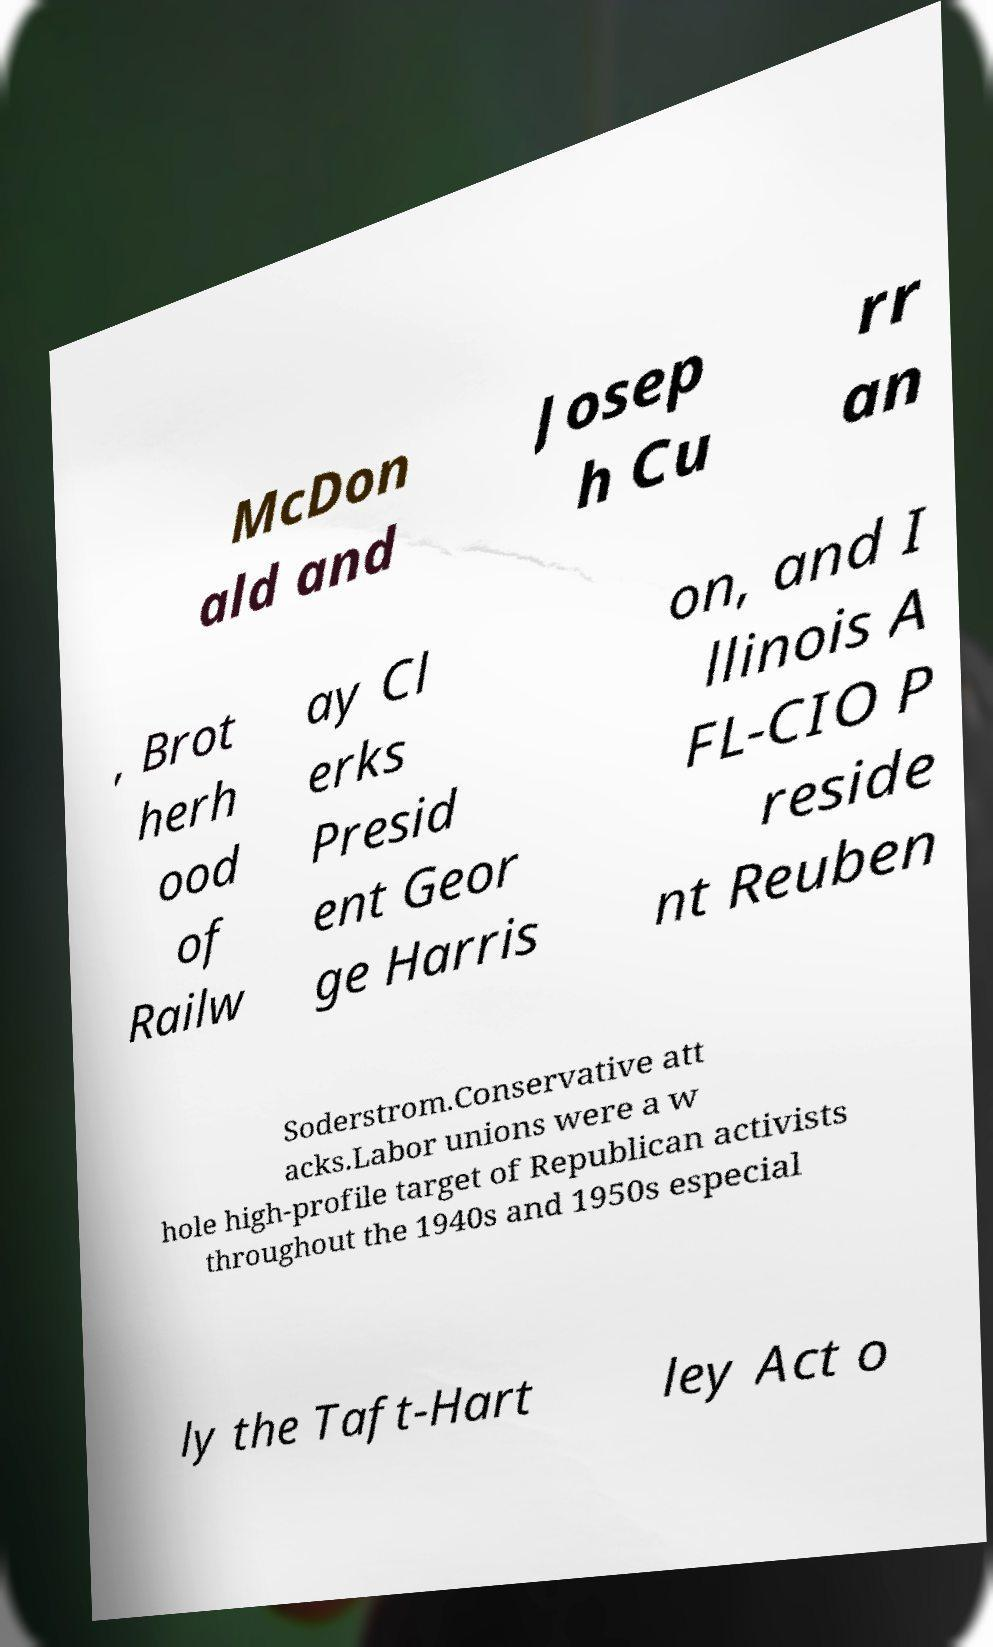I need the written content from this picture converted into text. Can you do that? McDon ald and Josep h Cu rr an , Brot herh ood of Railw ay Cl erks Presid ent Geor ge Harris on, and I llinois A FL-CIO P reside nt Reuben Soderstrom.Conservative att acks.Labor unions were a w hole high-profile target of Republican activists throughout the 1940s and 1950s especial ly the Taft-Hart ley Act o 